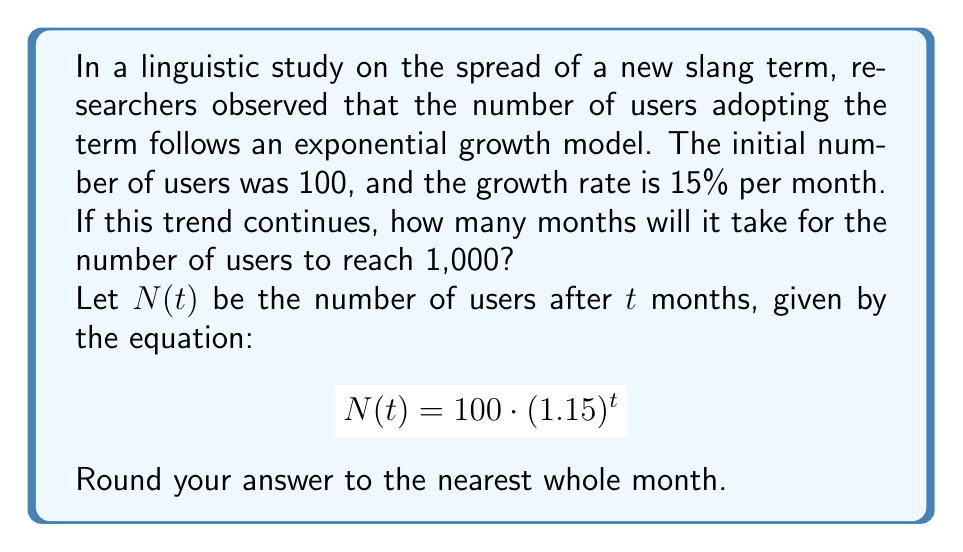Can you solve this math problem? To solve this problem, we need to use the exponential growth formula and solve for t:

1) We start with the exponential growth equation:
   $$N(t) = 100 \cdot (1.15)^t$$

2) We want to find t when N(t) = 1000, so we set up the equation:
   $$1000 = 100 \cdot (1.15)^t$$

3) Divide both sides by 100:
   $$10 = (1.15)^t$$

4) Take the natural logarithm of both sides:
   $$\ln(10) = \ln((1.15)^t)$$

5) Use the logarithm property $\ln(a^b) = b\ln(a)$:
   $$\ln(10) = t \cdot \ln(1.15)$$

6) Solve for t:
   $$t = \frac{\ln(10)}{\ln(1.15)}$$

7) Calculate the result:
   $$t \approx 16.0775$$

8) Rounding to the nearest whole month:
   $$t \approx 16$$

Therefore, it will take approximately 16 months for the number of users to reach 1,000.
Answer: 16 months 